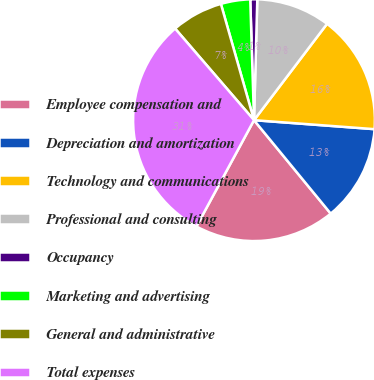Convert chart. <chart><loc_0><loc_0><loc_500><loc_500><pie_chart><fcel>Employee compensation and<fcel>Depreciation and amortization<fcel>Technology and communications<fcel>Professional and consulting<fcel>Occupancy<fcel>Marketing and advertising<fcel>General and administrative<fcel>Total expenses<nl><fcel>18.84%<fcel>12.87%<fcel>15.86%<fcel>9.89%<fcel>0.93%<fcel>3.92%<fcel>6.9%<fcel>30.78%<nl></chart> 